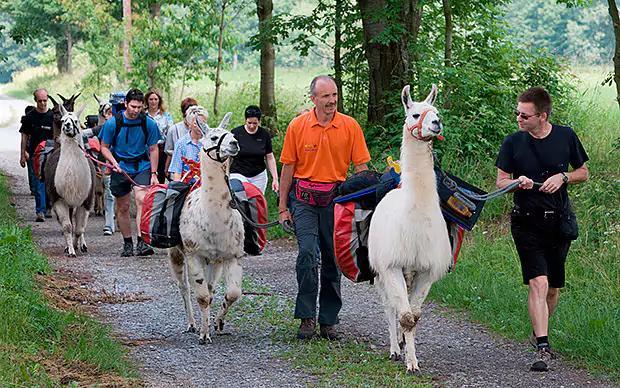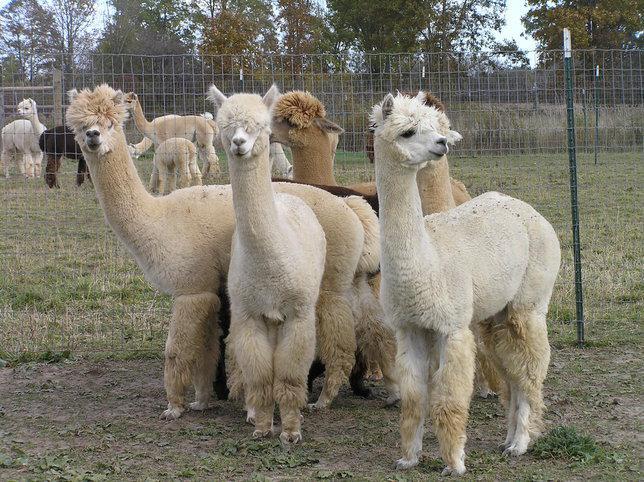The first image is the image on the left, the second image is the image on the right. For the images shown, is this caption "One image shows a close-together group of several llamas with bodies turned forward, and the other image includes a person standing to the right of and looking at a llama while holding a rope attached to it." true? Answer yes or no. Yes. The first image is the image on the left, the second image is the image on the right. Evaluate the accuracy of this statement regarding the images: "At least one person is standing outside with the animals in one of the images.". Is it true? Answer yes or no. Yes. 